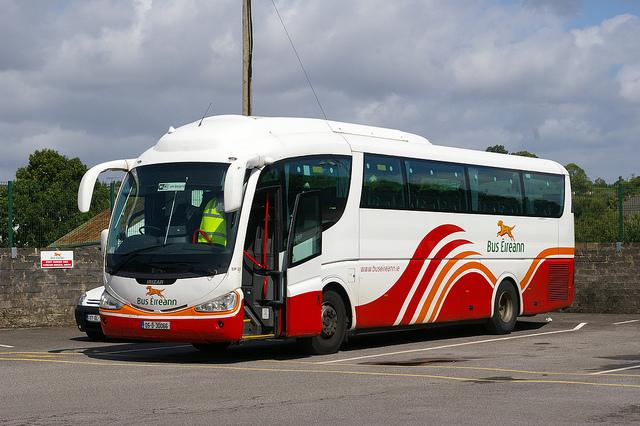Why is the man wearing a yellow vest? safety 